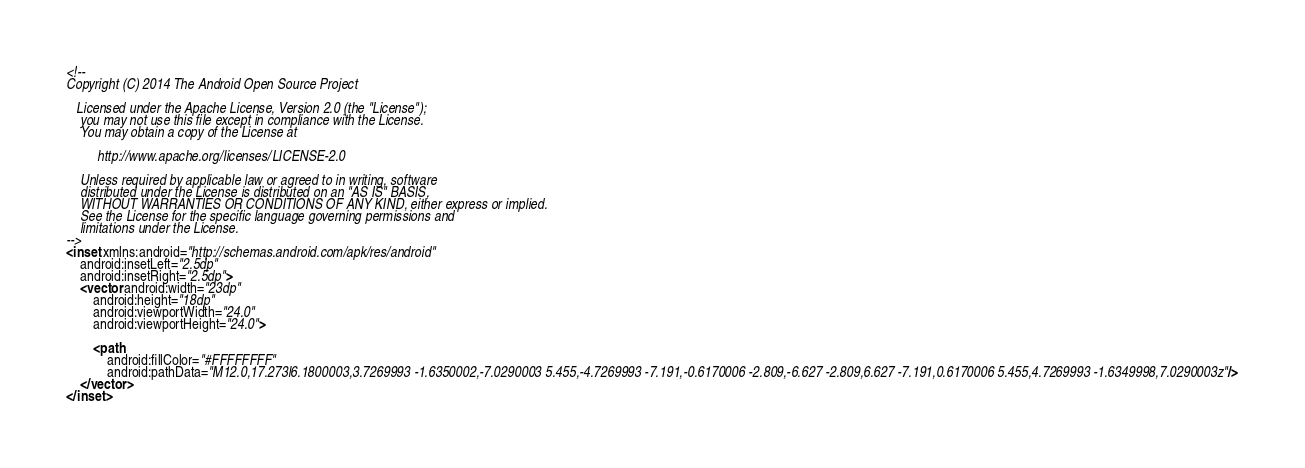<code> <loc_0><loc_0><loc_500><loc_500><_XML_><!--
Copyright (C) 2014 The Android Open Source Project

   Licensed under the Apache License, Version 2.0 (the "License");
    you may not use this file except in compliance with the License.
    You may obtain a copy of the License at

         http://www.apache.org/licenses/LICENSE-2.0

    Unless required by applicable law or agreed to in writing, software
    distributed under the License is distributed on an "AS IS" BASIS,
    WITHOUT WARRANTIES OR CONDITIONS OF ANY KIND, either express or implied.
    See the License for the specific language governing permissions and
    limitations under the License.
-->
<inset xmlns:android="http://schemas.android.com/apk/res/android"
    android:insetLeft="2.5dp"
    android:insetRight="2.5dp">
    <vector android:width="23dp"
        android:height="18dp"
        android:viewportWidth="24.0"
        android:viewportHeight="24.0">

        <path
            android:fillColor="#FFFFFFFF"
            android:pathData="M12.0,17.273l6.1800003,3.7269993 -1.6350002,-7.0290003 5.455,-4.7269993 -7.191,-0.6170006 -2.809,-6.627 -2.809,6.627 -7.191,0.6170006 5.455,4.7269993 -1.6349998,7.0290003z"/>
    </vector>
</inset></code> 